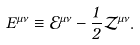<formula> <loc_0><loc_0><loc_500><loc_500>E ^ { \mu \nu } \equiv \mathcal { E } ^ { \mu \nu } - { \frac { 1 } { 2 } } \mathcal { Z } ^ { \mu \nu } .</formula> 